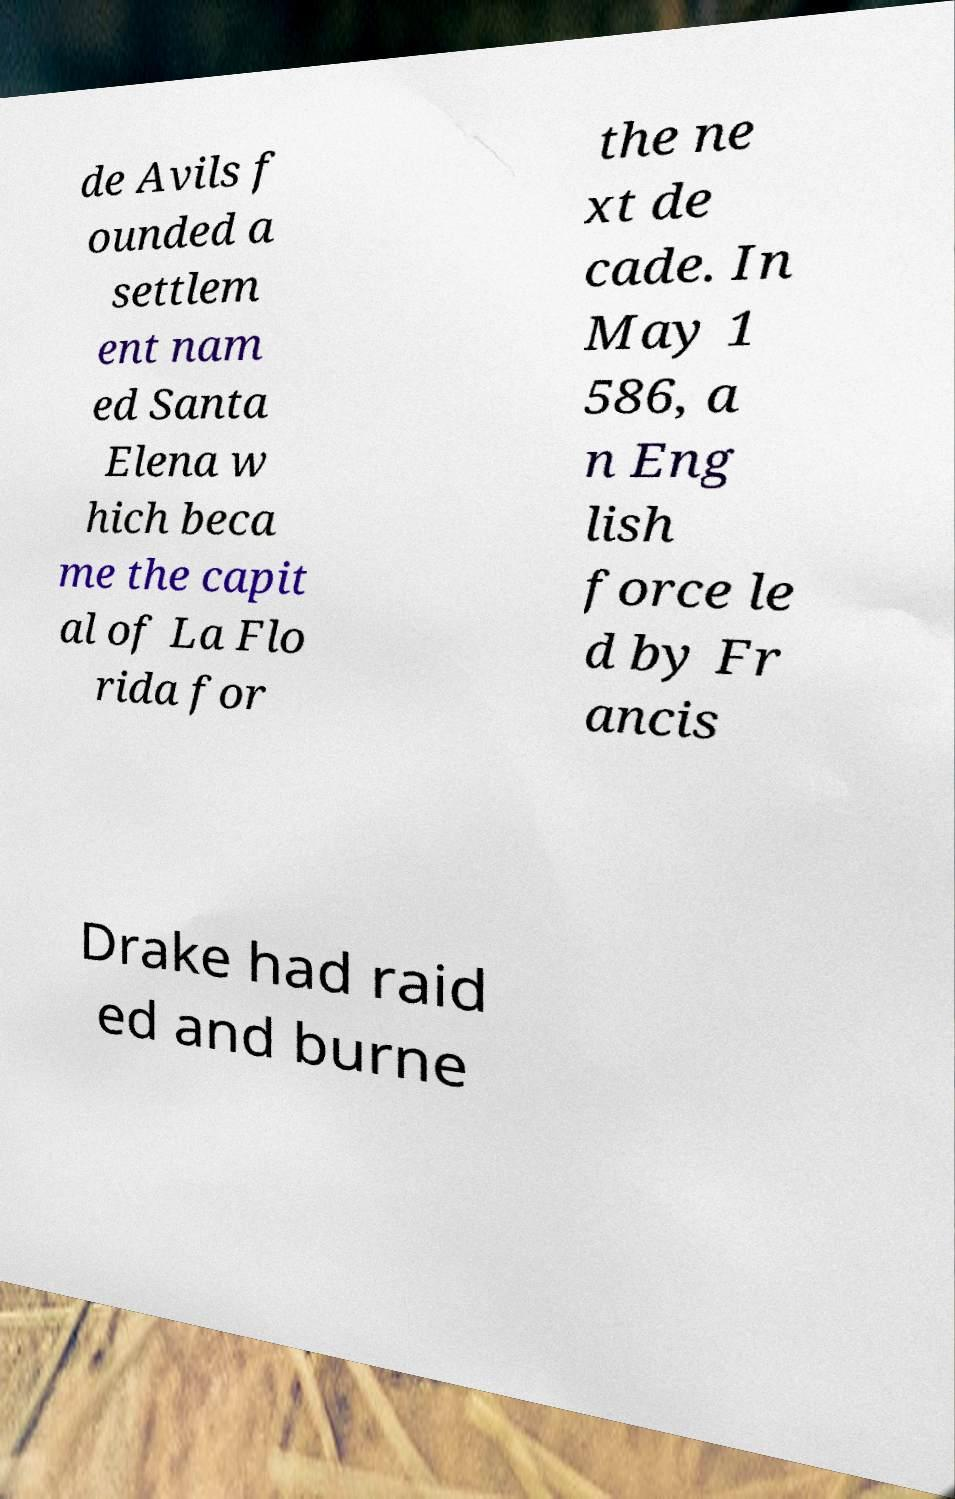Please read and relay the text visible in this image. What does it say? de Avils f ounded a settlem ent nam ed Santa Elena w hich beca me the capit al of La Flo rida for the ne xt de cade. In May 1 586, a n Eng lish force le d by Fr ancis Drake had raid ed and burne 